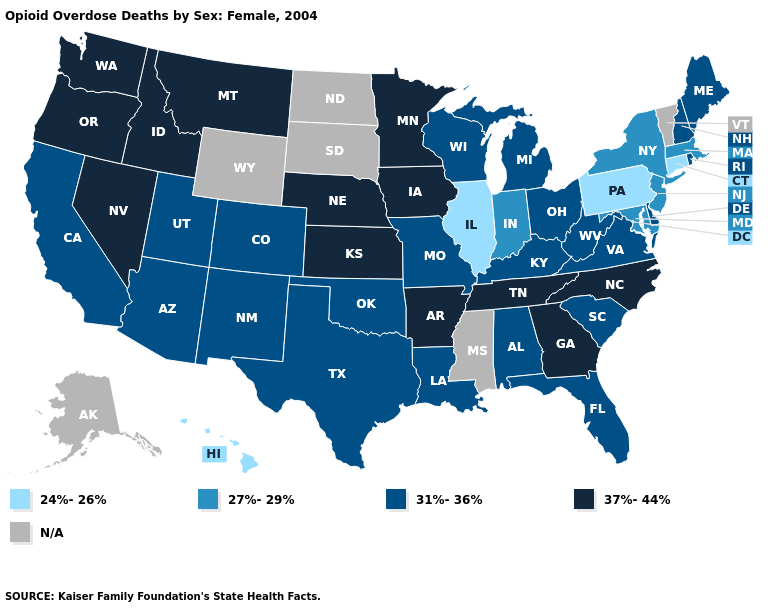What is the highest value in the USA?
Write a very short answer. 37%-44%. Which states have the highest value in the USA?
Write a very short answer. Arkansas, Georgia, Idaho, Iowa, Kansas, Minnesota, Montana, Nebraska, Nevada, North Carolina, Oregon, Tennessee, Washington. What is the highest value in the USA?
Quick response, please. 37%-44%. Among the states that border Colorado , does Kansas have the highest value?
Give a very brief answer. Yes. What is the lowest value in the South?
Answer briefly. 27%-29%. What is the value of Idaho?
Quick response, please. 37%-44%. What is the highest value in the South ?
Concise answer only. 37%-44%. Which states have the highest value in the USA?
Answer briefly. Arkansas, Georgia, Idaho, Iowa, Kansas, Minnesota, Montana, Nebraska, Nevada, North Carolina, Oregon, Tennessee, Washington. Among the states that border Georgia , which have the highest value?
Write a very short answer. North Carolina, Tennessee. How many symbols are there in the legend?
Concise answer only. 5. What is the highest value in the USA?
Write a very short answer. 37%-44%. Does Hawaii have the lowest value in the West?
Give a very brief answer. Yes. Which states have the lowest value in the South?
Give a very brief answer. Maryland. Name the states that have a value in the range 24%-26%?
Concise answer only. Connecticut, Hawaii, Illinois, Pennsylvania. 